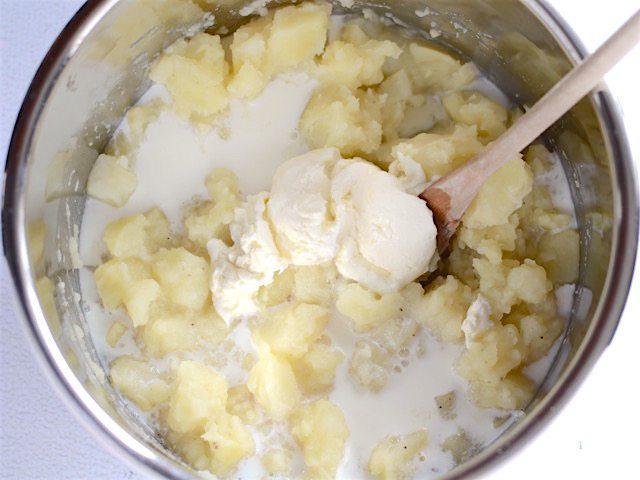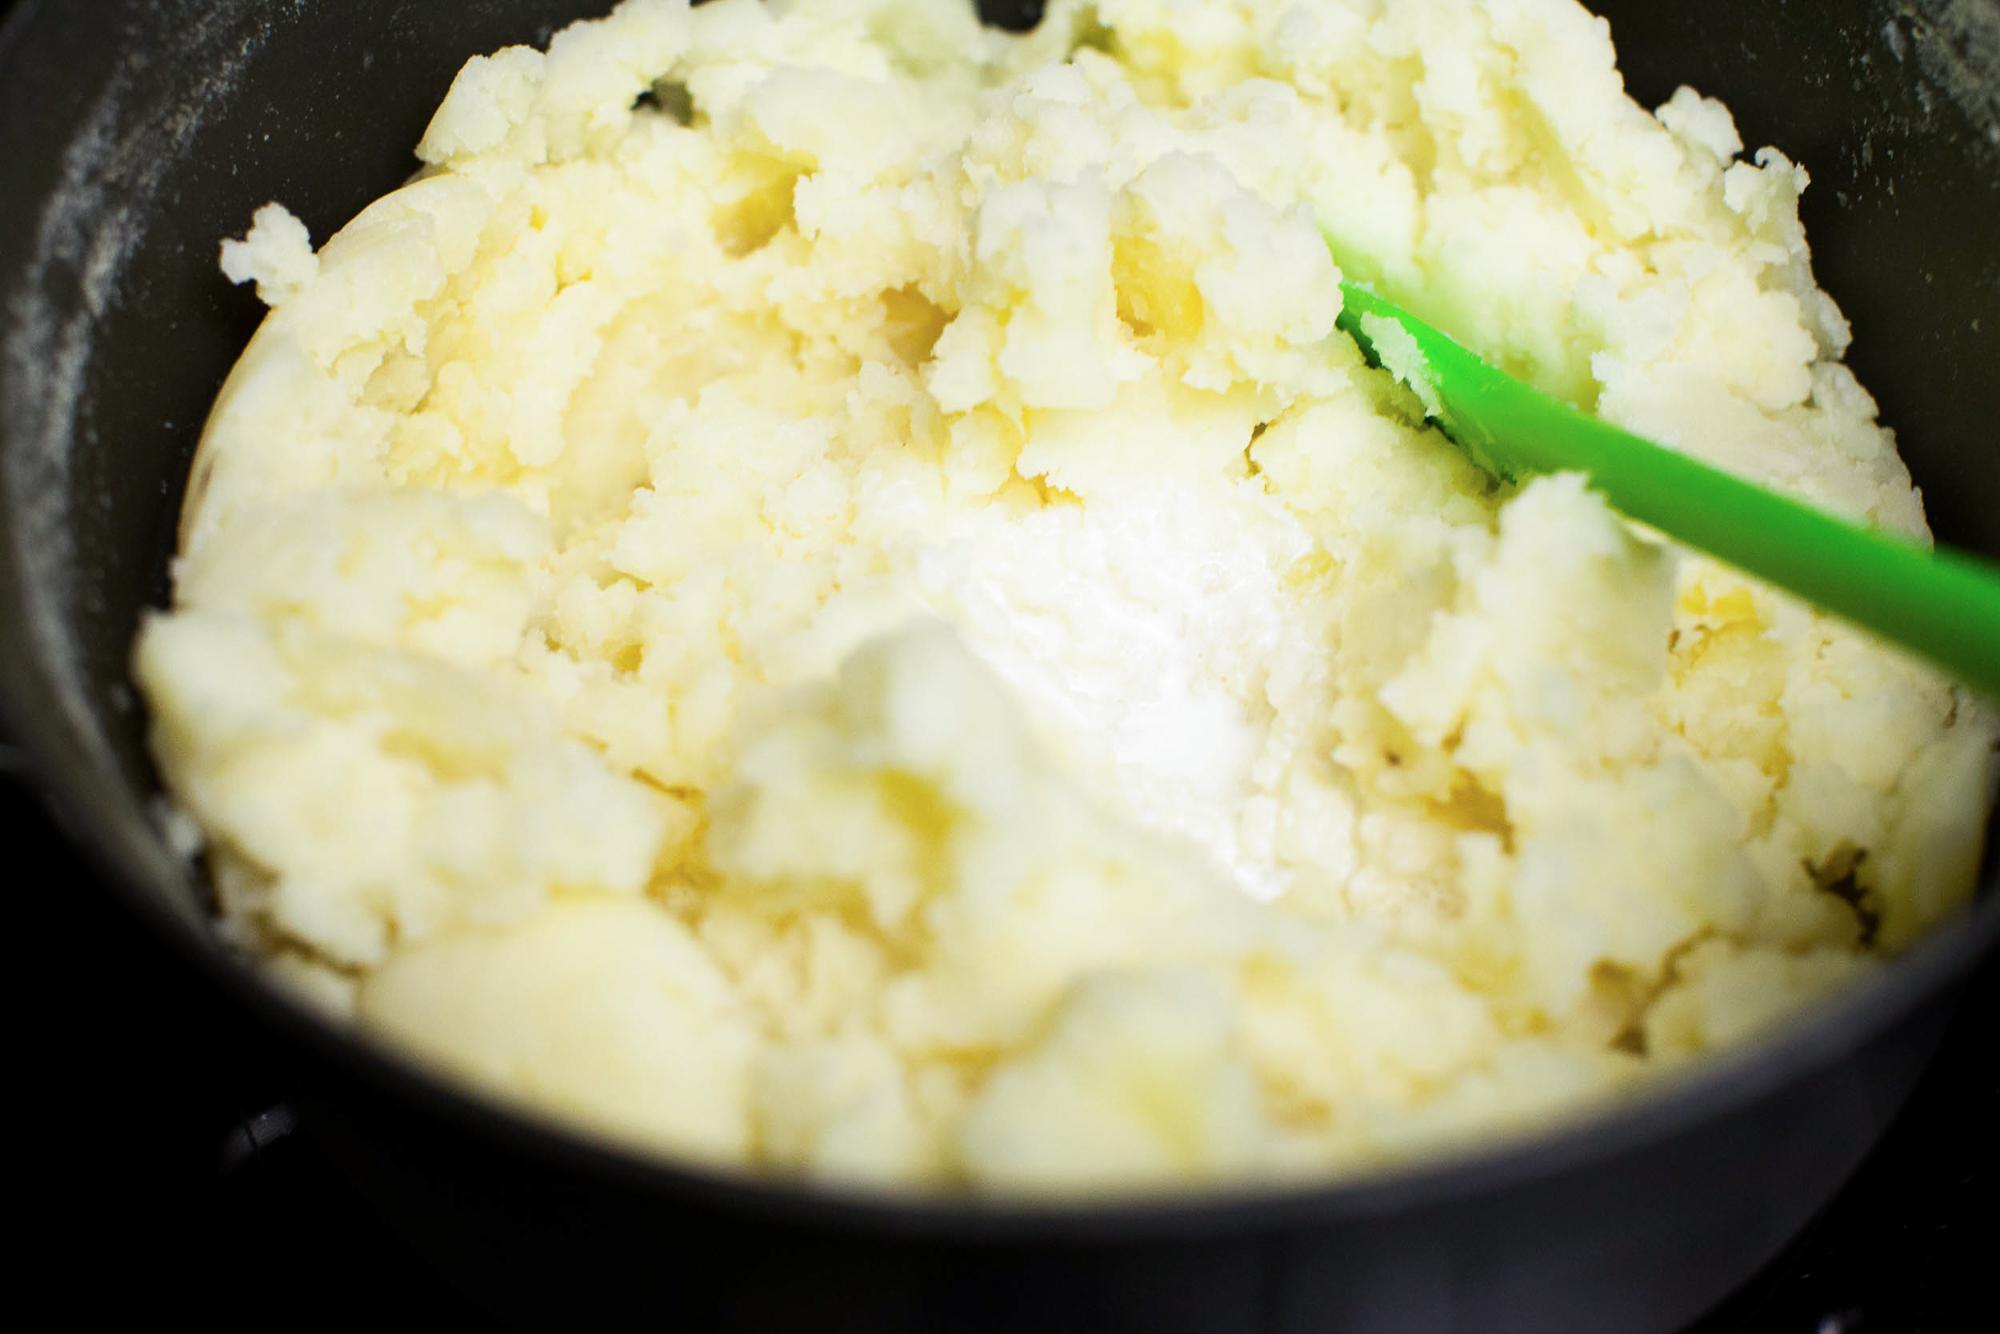The first image is the image on the left, the second image is the image on the right. Considering the images on both sides, is "There is a spoon in the food on the right, but not on the left." valid? Answer yes or no. No. 